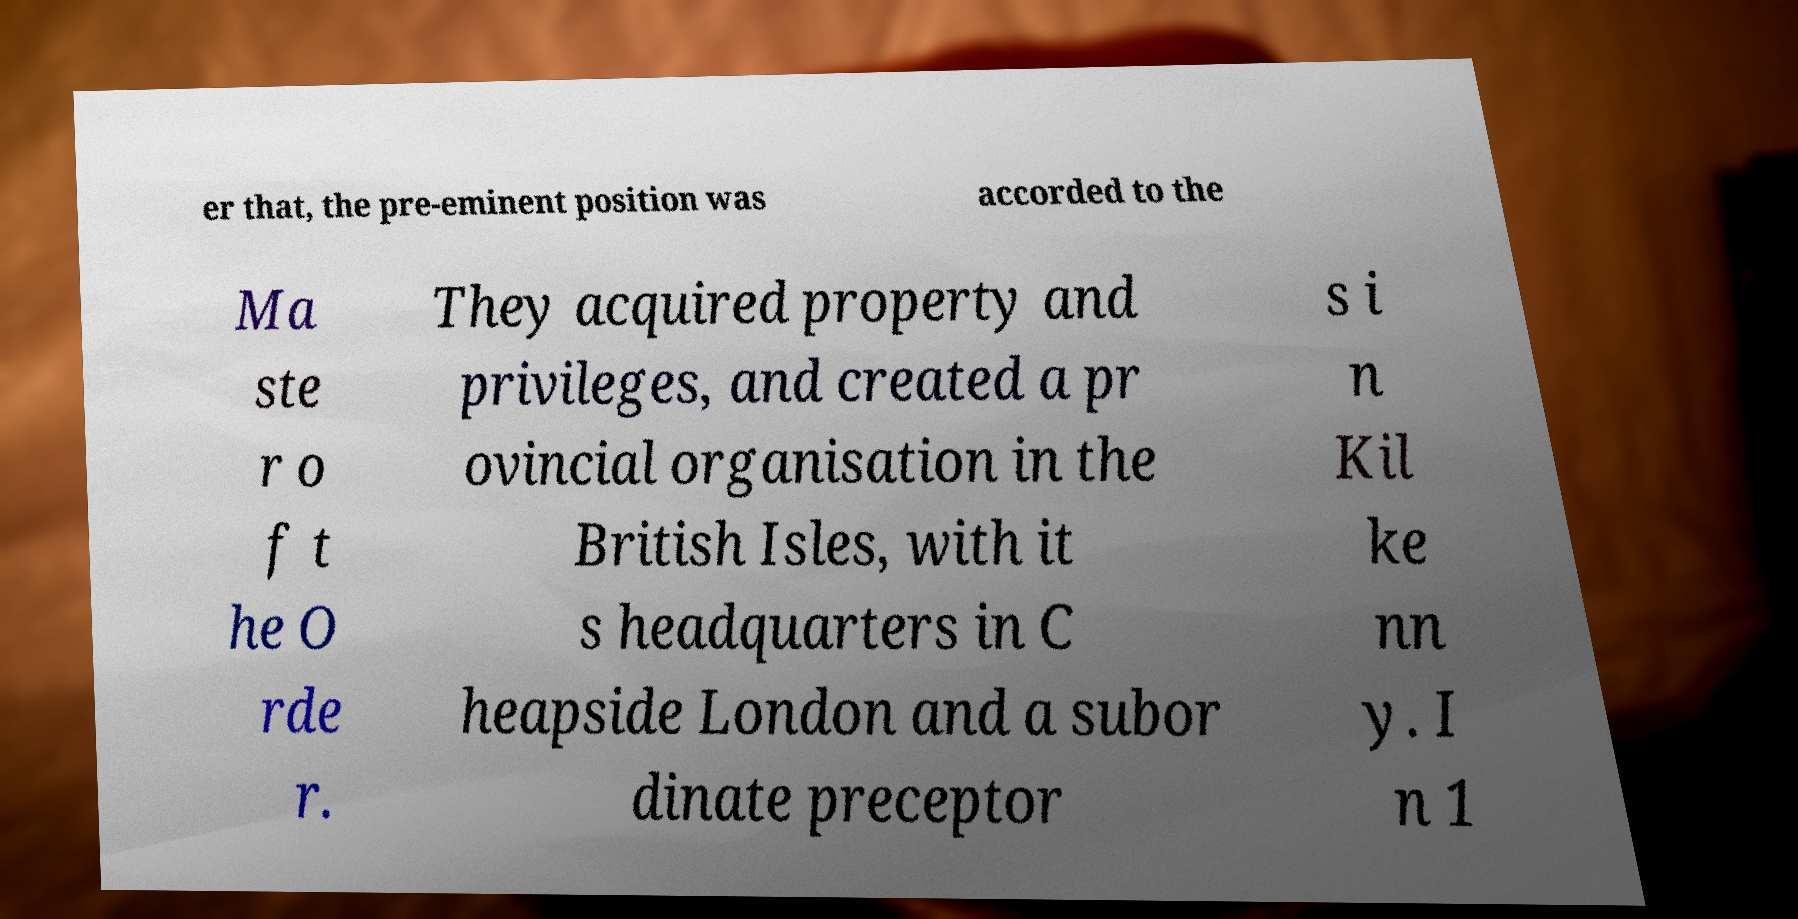For documentation purposes, I need the text within this image transcribed. Could you provide that? er that, the pre-eminent position was accorded to the Ma ste r o f t he O rde r. They acquired property and privileges, and created a pr ovincial organisation in the British Isles, with it s headquarters in C heapside London and a subor dinate preceptor s i n Kil ke nn y. I n 1 